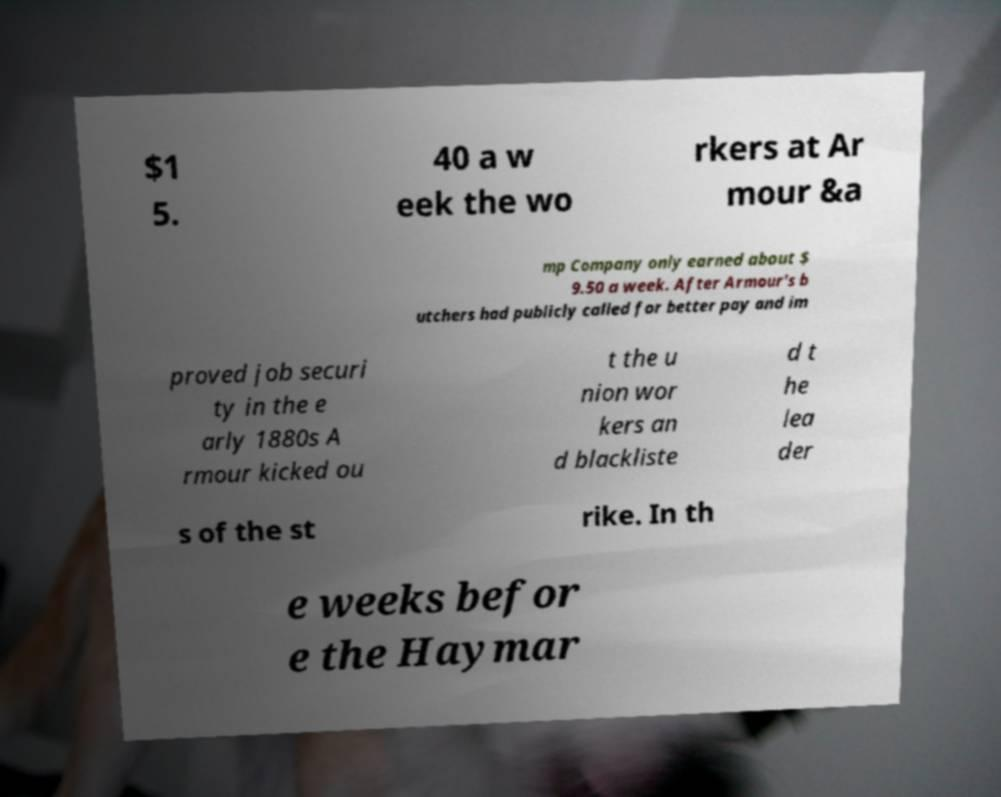Please read and relay the text visible in this image. What does it say? $1 5. 40 a w eek the wo rkers at Ar mour &a mp Company only earned about $ 9.50 a week. After Armour's b utchers had publicly called for better pay and im proved job securi ty in the e arly 1880s A rmour kicked ou t the u nion wor kers an d blackliste d t he lea der s of the st rike. In th e weeks befor e the Haymar 